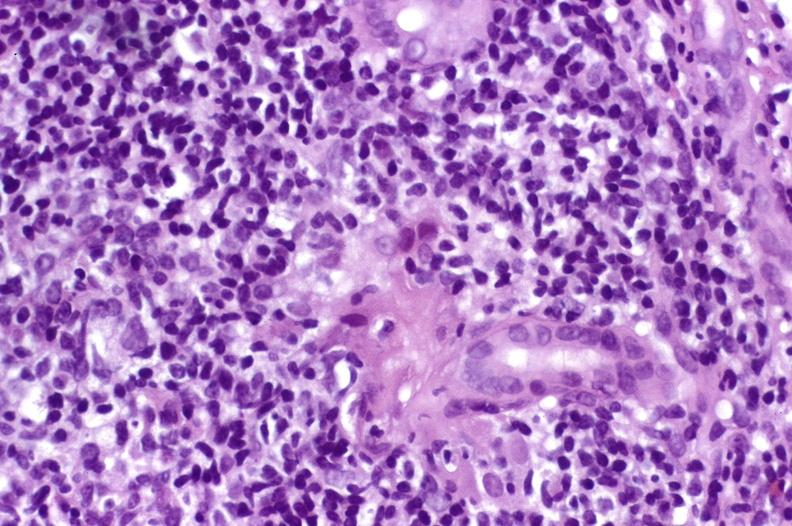what is present?
Answer the question using a single word or phrase. Liver 